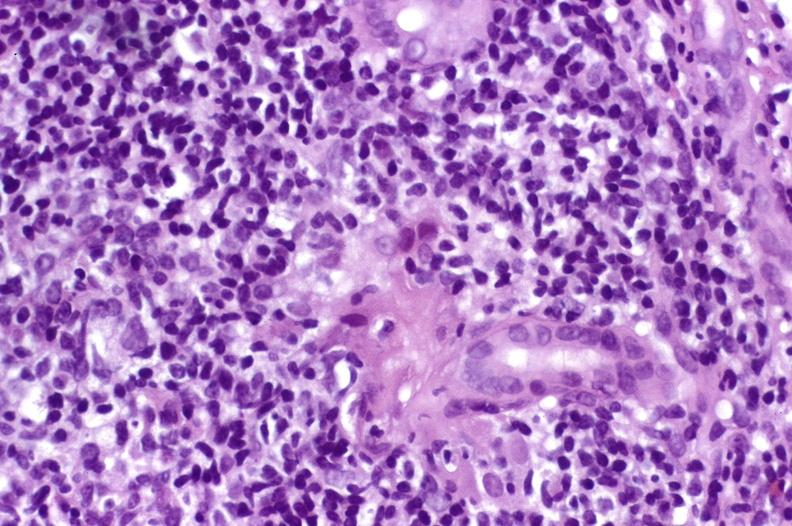what is present?
Answer the question using a single word or phrase. Liver 